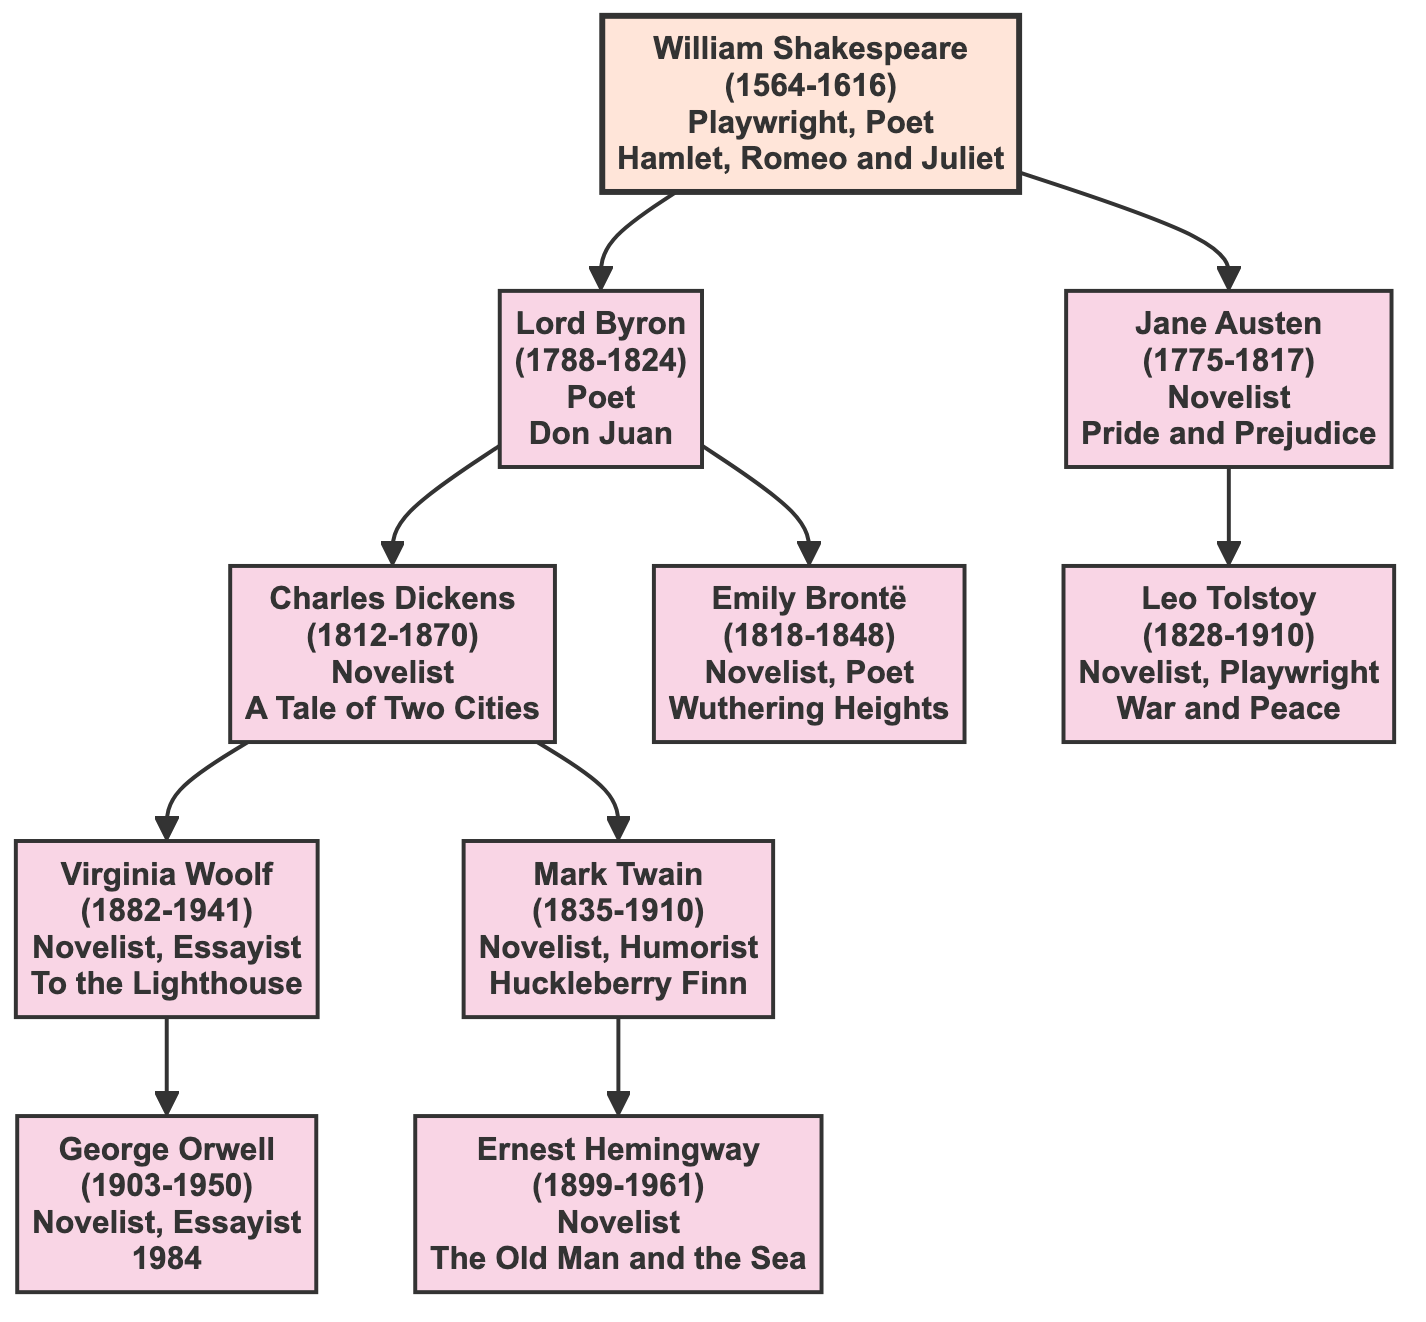What is the profession of William Shakespeare? According to the diagram, William Shakespeare's profession is listed as "Playwright, Poet".
Answer: Playwright, Poet Who are the descendants of Lord Byron? The diagram shows that Lord Byron has two descendants: Charles Dickens and Emily Brontë.
Answer: Charles Dickens, Emily Brontë How many notable works did Jane Austen have? The diagram indicates that Jane Austen has two notable works: "Pride and Prejudice" and "Sense and Sensibility".
Answer: 2 Which author is a descendant of Charles Dickens? From the diagram, Charles Dickens has two descendants: Virginia Woolf and Mark Twain. Thus, both are descendants of Charles Dickens.
Answer: Virginia Woolf, Mark Twain Who is the direct descendant of William Shakespeare that is a poet? Looking at the diagram, Lord Byron is the direct descendant of William Shakespeare and is identified as a poet.
Answer: Lord Byron What is the birth year of Ernest Hemingway? The diagram lists that Ernest Hemingway was born in 1899.
Answer: 1899 Which novelist is a descendant of Lord Byron and has written "1984"? The diagram reveals that the author who wrote "1984" is George Orwell, who is a descendant of Virginia Woolf, who is in turn a descendant of Charles Dickens, a descendant of Lord Byron.
Answer: George Orwell Name one notable work of Virginia Woolf. From the diagram, one notable work of Virginia Woolf is "To the Lighthouse".
Answer: To the Lighthouse Who is the only author in this family tree that is known primarily as a humorist? The diagram indicates that Mark Twain is described as a "Novelist, Humorist", making him the only author primarily known as a humorist.
Answer: Mark Twain 